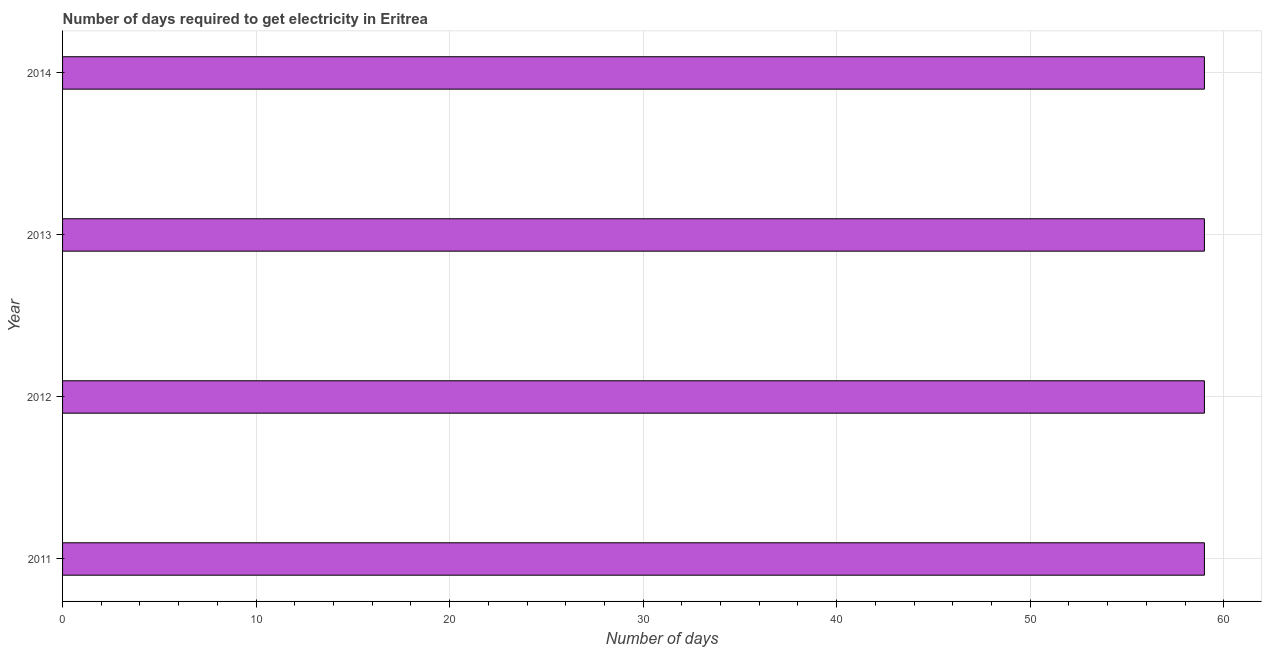What is the title of the graph?
Your response must be concise. Number of days required to get electricity in Eritrea. What is the label or title of the X-axis?
Your answer should be very brief. Number of days. What is the label or title of the Y-axis?
Keep it short and to the point. Year. In which year was the time to get electricity maximum?
Offer a very short reply. 2011. In which year was the time to get electricity minimum?
Give a very brief answer. 2011. What is the sum of the time to get electricity?
Your answer should be very brief. 236. What is the difference between the time to get electricity in 2013 and 2014?
Your answer should be very brief. 0. What is the average time to get electricity per year?
Provide a short and direct response. 59. What is the median time to get electricity?
Provide a succinct answer. 59. Do a majority of the years between 2011 and 2012 (inclusive) have time to get electricity greater than 28 ?
Give a very brief answer. Yes. What is the ratio of the time to get electricity in 2011 to that in 2012?
Your response must be concise. 1. Is the time to get electricity in 2011 less than that in 2012?
Make the answer very short. No. What is the difference between the highest and the second highest time to get electricity?
Provide a short and direct response. 0. In how many years, is the time to get electricity greater than the average time to get electricity taken over all years?
Make the answer very short. 0. How many bars are there?
Provide a short and direct response. 4. Are all the bars in the graph horizontal?
Keep it short and to the point. Yes. How many years are there in the graph?
Keep it short and to the point. 4. What is the Number of days of 2011?
Your response must be concise. 59. What is the Number of days of 2014?
Your response must be concise. 59. What is the difference between the Number of days in 2011 and 2013?
Offer a very short reply. 0. What is the difference between the Number of days in 2011 and 2014?
Ensure brevity in your answer.  0. What is the difference between the Number of days in 2012 and 2014?
Ensure brevity in your answer.  0. What is the ratio of the Number of days in 2011 to that in 2013?
Offer a terse response. 1. What is the ratio of the Number of days in 2011 to that in 2014?
Give a very brief answer. 1. What is the ratio of the Number of days in 2012 to that in 2013?
Your answer should be very brief. 1. 